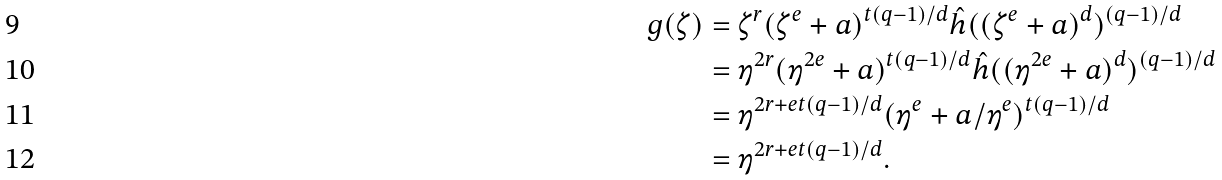<formula> <loc_0><loc_0><loc_500><loc_500>g ( \zeta ) & = \zeta ^ { r } ( \zeta ^ { e } + a ) ^ { t ( q - 1 ) / d } \hat { h } ( ( \zeta ^ { e } + a ) ^ { d } ) ^ { ( q - 1 ) / d } \\ & = \eta ^ { 2 r } ( \eta ^ { 2 e } + a ) ^ { t ( q - 1 ) / d } \hat { h } ( ( \eta ^ { 2 e } + a ) ^ { d } ) ^ { ( q - 1 ) / d } \\ & = \eta ^ { 2 r + e t ( q - 1 ) / d } ( \eta ^ { e } + a / \eta ^ { e } ) ^ { t ( q - 1 ) / d } \\ & = \eta ^ { 2 r + e t ( q - 1 ) / d } .</formula> 